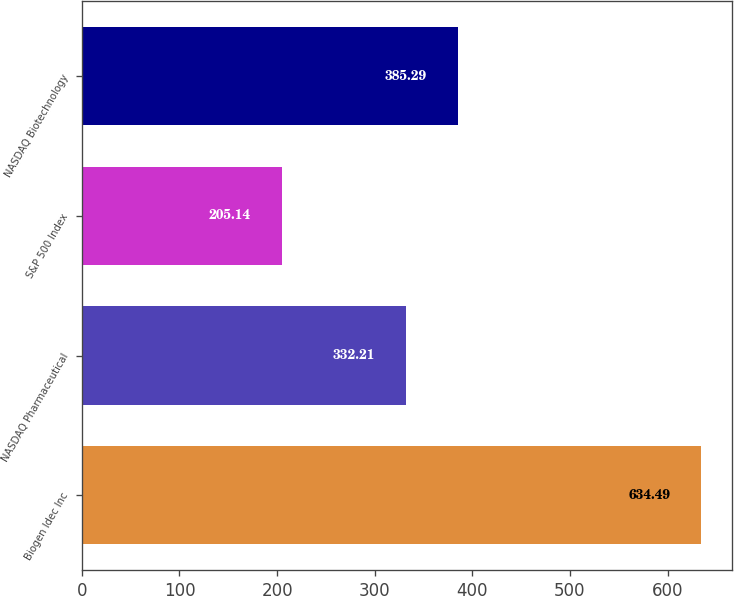Convert chart to OTSL. <chart><loc_0><loc_0><loc_500><loc_500><bar_chart><fcel>Biogen Idec Inc<fcel>NASDAQ Pharmaceutical<fcel>S&P 500 Index<fcel>NASDAQ Biotechnology<nl><fcel>634.49<fcel>332.21<fcel>205.14<fcel>385.29<nl></chart> 